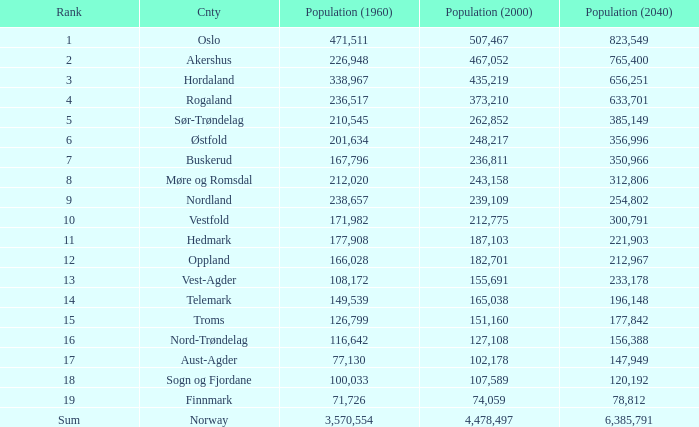What was the population of a county in 2040 that had a population less than 108,172 in 2000 and less than 107,589 in 1960? 2.0. 